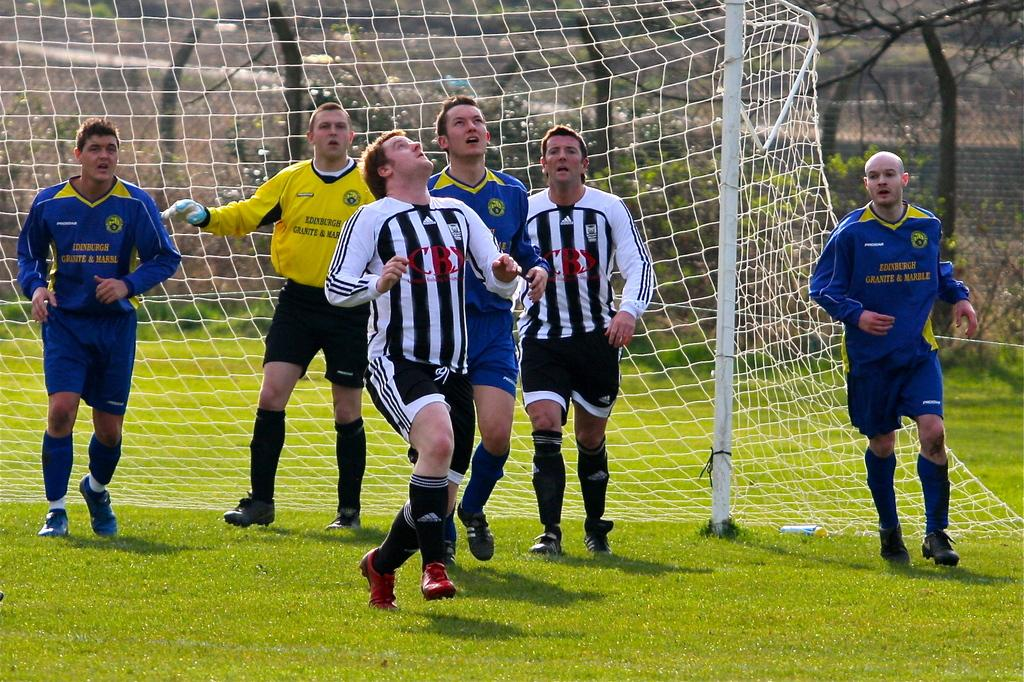How many people are in the image? There is a group of people in the image, but the exact number cannot be determined from the provided facts. What might the people be doing in the image? The people might be running, as suggested by the fact that they are in a group and there is a net at the back. What can be seen in the background of the image? Trees and a fence are visible in the background of the image. What is the ground made of in the image? The ground is made of grass, as seen at the bottom of the image. What type of door can be seen in the image? There is no door present in the image. What magical powers do the people in the image possess? There is no mention of magic or magical powers in the image. 